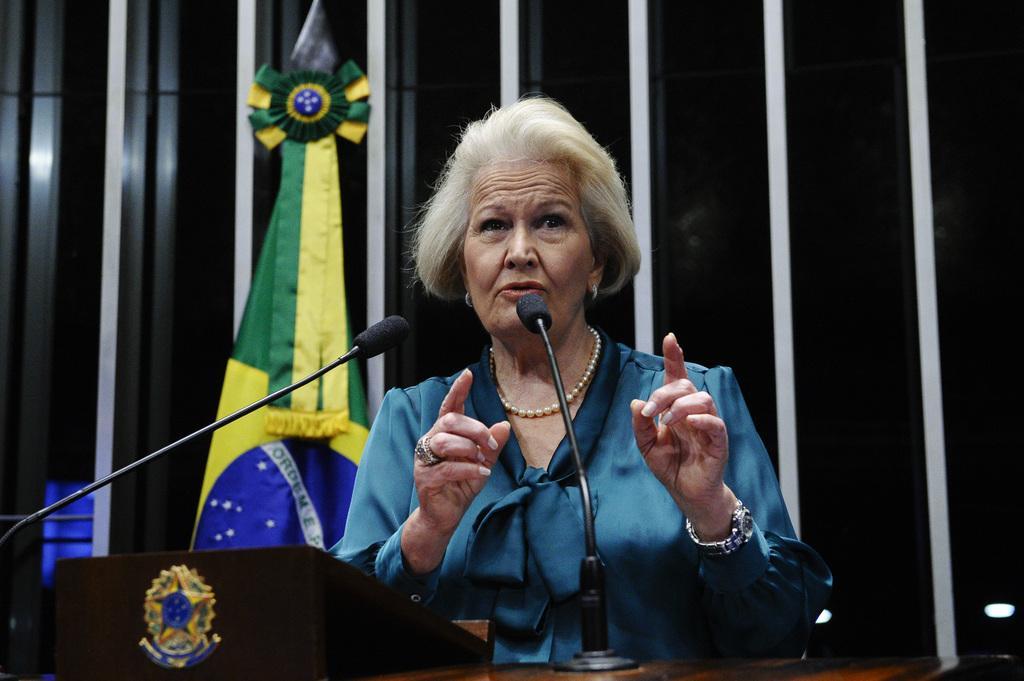Could you give a brief overview of what you see in this image? This image is taken indoors. In the background there is a wall and there is a flag. At the bottom of the image there is a podium with two mics on it. In the middle of the image a woman is standing and talking. 